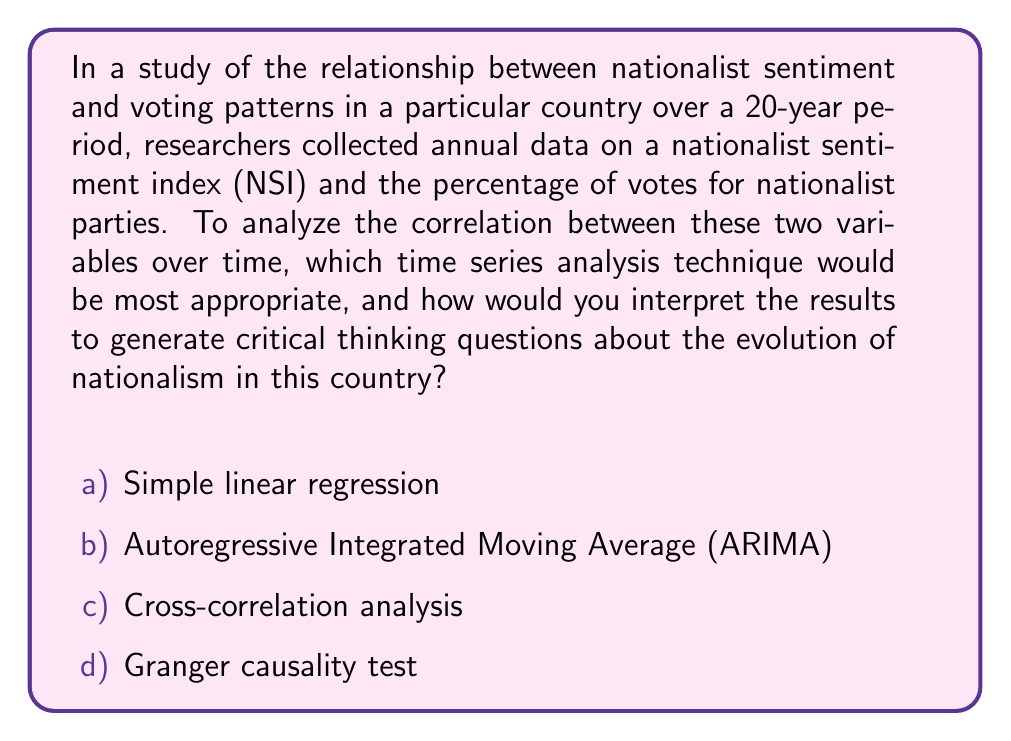Teach me how to tackle this problem. To analyze the correlation between nationalist sentiment and voting patterns over time, we need to consider that both variables are time series data. This requires a specific approach to account for the temporal nature of the data.

1. Simple linear regression is not appropriate for time series data as it assumes independence between observations, which is often violated in time series.

2. ARIMA models are used for forecasting a single time series, not for analyzing the relationship between two series.

3. Cross-correlation analysis is the most appropriate technique for this scenario. It measures the correlation between two time series at different time lags. The cross-correlation function (CCF) is defined as:

   $$\rho_{xy}(k) = \frac{\gamma_{xy}(k)}{\sqrt{\gamma_{xx}(0)\gamma_{yy}(0)}}$$

   where $\gamma_{xy}(k)$ is the cross-covariance function, and $\gamma_{xx}(0)$ and $\gamma_{yy}(0)$ are the variances of the two series.

4. Granger causality test is used to determine if one time series is useful in forecasting another, but it doesn't directly measure correlation.

Cross-correlation analysis allows us to examine:

a) The strength of the relationship between NSI and voting patterns.
b) The direction of the relationship (positive or negative correlation).
c) Any time lags between changes in NSI and corresponding changes in voting patterns.

Interpreting the results:

- If the CCF shows a strong positive correlation at lag 0, it suggests that increases in nationalist sentiment are associated with immediate increases in votes for nationalist parties.
- If the strongest correlation occurs at a positive lag, it might indicate that changes in nationalist sentiment precede changes in voting patterns.
- If the strongest correlation is at a negative lag, it could suggest that voting patterns influence nationalist sentiment.

These interpretations can lead to critical thinking questions about the nature of nationalism, such as:

1. How does the media's portrayal of nationalist ideologies impact public sentiment and voting behavior?
2. What historical events might explain sudden shifts in the correlation between nationalist sentiment and voting patterns?
3. How do economic factors interplay with nationalist sentiment and voting behavior over time?
Answer: c) Cross-correlation analysis 